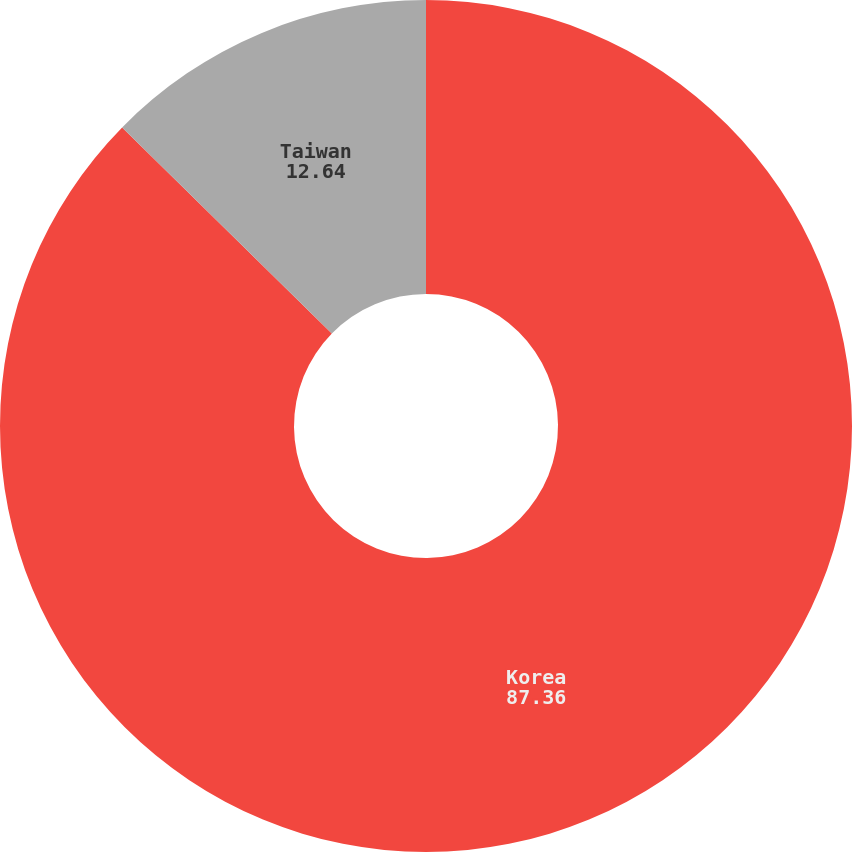Convert chart. <chart><loc_0><loc_0><loc_500><loc_500><pie_chart><fcel>Korea<fcel>Taiwan<nl><fcel>87.36%<fcel>12.64%<nl></chart> 